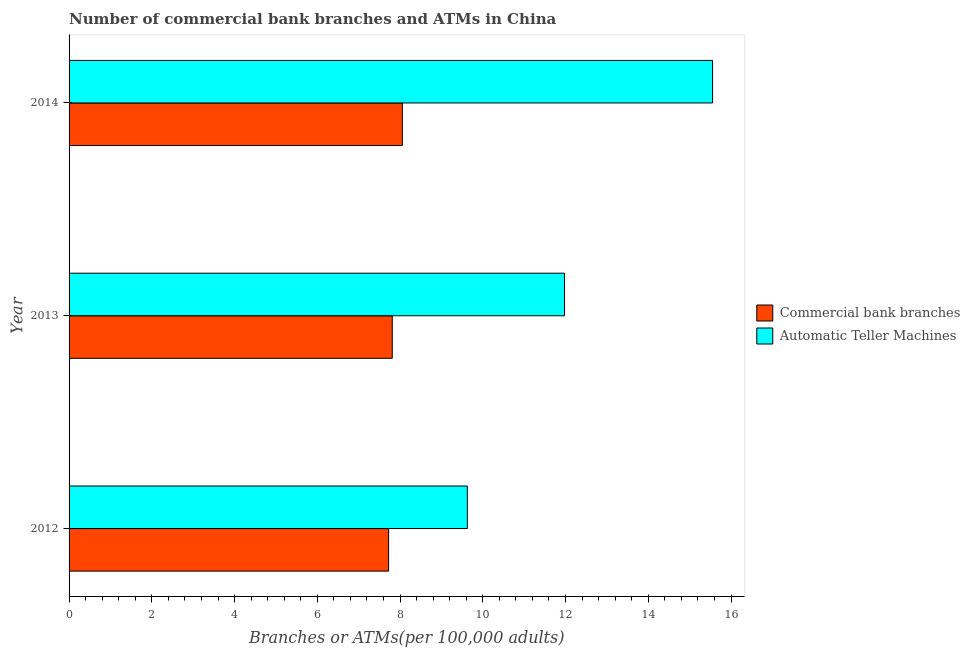How many different coloured bars are there?
Ensure brevity in your answer.  2. How many groups of bars are there?
Make the answer very short. 3. How many bars are there on the 1st tick from the top?
Keep it short and to the point. 2. How many bars are there on the 2nd tick from the bottom?
Keep it short and to the point. 2. What is the number of atms in 2014?
Your answer should be compact. 15.55. Across all years, what is the maximum number of commercal bank branches?
Give a very brief answer. 8.06. Across all years, what is the minimum number of commercal bank branches?
Make the answer very short. 7.72. In which year was the number of commercal bank branches maximum?
Offer a terse response. 2014. In which year was the number of commercal bank branches minimum?
Give a very brief answer. 2012. What is the total number of atms in the graph?
Keep it short and to the point. 37.16. What is the difference between the number of commercal bank branches in 2012 and that in 2013?
Provide a succinct answer. -0.09. What is the difference between the number of commercal bank branches in 2014 and the number of atms in 2013?
Your response must be concise. -3.92. What is the average number of commercal bank branches per year?
Offer a very short reply. 7.86. In the year 2014, what is the difference between the number of commercal bank branches and number of atms?
Your answer should be very brief. -7.5. What is the difference between the highest and the second highest number of atms?
Offer a very short reply. 3.58. What is the difference between the highest and the lowest number of commercal bank branches?
Provide a short and direct response. 0.33. In how many years, is the number of atms greater than the average number of atms taken over all years?
Ensure brevity in your answer.  1. Is the sum of the number of commercal bank branches in 2012 and 2013 greater than the maximum number of atms across all years?
Your answer should be compact. No. What does the 2nd bar from the top in 2012 represents?
Make the answer very short. Commercial bank branches. What does the 2nd bar from the bottom in 2014 represents?
Provide a succinct answer. Automatic Teller Machines. Are all the bars in the graph horizontal?
Your answer should be very brief. Yes. How many years are there in the graph?
Give a very brief answer. 3. What is the difference between two consecutive major ticks on the X-axis?
Provide a short and direct response. 2. Are the values on the major ticks of X-axis written in scientific E-notation?
Your answer should be very brief. No. How are the legend labels stacked?
Offer a terse response. Vertical. What is the title of the graph?
Your answer should be compact. Number of commercial bank branches and ATMs in China. What is the label or title of the X-axis?
Ensure brevity in your answer.  Branches or ATMs(per 100,0 adults). What is the Branches or ATMs(per 100,000 adults) of Commercial bank branches in 2012?
Offer a terse response. 7.72. What is the Branches or ATMs(per 100,000 adults) in Automatic Teller Machines in 2012?
Provide a succinct answer. 9.63. What is the Branches or ATMs(per 100,000 adults) in Commercial bank branches in 2013?
Ensure brevity in your answer.  7.81. What is the Branches or ATMs(per 100,000 adults) in Automatic Teller Machines in 2013?
Provide a succinct answer. 11.98. What is the Branches or ATMs(per 100,000 adults) in Commercial bank branches in 2014?
Offer a terse response. 8.06. What is the Branches or ATMs(per 100,000 adults) in Automatic Teller Machines in 2014?
Your response must be concise. 15.55. Across all years, what is the maximum Branches or ATMs(per 100,000 adults) of Commercial bank branches?
Offer a terse response. 8.06. Across all years, what is the maximum Branches or ATMs(per 100,000 adults) of Automatic Teller Machines?
Ensure brevity in your answer.  15.55. Across all years, what is the minimum Branches or ATMs(per 100,000 adults) of Commercial bank branches?
Offer a terse response. 7.72. Across all years, what is the minimum Branches or ATMs(per 100,000 adults) of Automatic Teller Machines?
Provide a succinct answer. 9.63. What is the total Branches or ATMs(per 100,000 adults) of Commercial bank branches in the graph?
Your answer should be very brief. 23.59. What is the total Branches or ATMs(per 100,000 adults) of Automatic Teller Machines in the graph?
Offer a terse response. 37.16. What is the difference between the Branches or ATMs(per 100,000 adults) in Commercial bank branches in 2012 and that in 2013?
Keep it short and to the point. -0.09. What is the difference between the Branches or ATMs(per 100,000 adults) of Automatic Teller Machines in 2012 and that in 2013?
Offer a terse response. -2.35. What is the difference between the Branches or ATMs(per 100,000 adults) of Commercial bank branches in 2012 and that in 2014?
Offer a terse response. -0.33. What is the difference between the Branches or ATMs(per 100,000 adults) of Automatic Teller Machines in 2012 and that in 2014?
Keep it short and to the point. -5.93. What is the difference between the Branches or ATMs(per 100,000 adults) of Commercial bank branches in 2013 and that in 2014?
Ensure brevity in your answer.  -0.24. What is the difference between the Branches or ATMs(per 100,000 adults) in Automatic Teller Machines in 2013 and that in 2014?
Offer a terse response. -3.58. What is the difference between the Branches or ATMs(per 100,000 adults) in Commercial bank branches in 2012 and the Branches or ATMs(per 100,000 adults) in Automatic Teller Machines in 2013?
Provide a succinct answer. -4.25. What is the difference between the Branches or ATMs(per 100,000 adults) in Commercial bank branches in 2012 and the Branches or ATMs(per 100,000 adults) in Automatic Teller Machines in 2014?
Offer a terse response. -7.83. What is the difference between the Branches or ATMs(per 100,000 adults) in Commercial bank branches in 2013 and the Branches or ATMs(per 100,000 adults) in Automatic Teller Machines in 2014?
Your answer should be very brief. -7.74. What is the average Branches or ATMs(per 100,000 adults) in Commercial bank branches per year?
Offer a terse response. 7.86. What is the average Branches or ATMs(per 100,000 adults) in Automatic Teller Machines per year?
Provide a succinct answer. 12.39. In the year 2012, what is the difference between the Branches or ATMs(per 100,000 adults) in Commercial bank branches and Branches or ATMs(per 100,000 adults) in Automatic Teller Machines?
Make the answer very short. -1.9. In the year 2013, what is the difference between the Branches or ATMs(per 100,000 adults) in Commercial bank branches and Branches or ATMs(per 100,000 adults) in Automatic Teller Machines?
Provide a succinct answer. -4.16. In the year 2014, what is the difference between the Branches or ATMs(per 100,000 adults) of Commercial bank branches and Branches or ATMs(per 100,000 adults) of Automatic Teller Machines?
Your answer should be very brief. -7.5. What is the ratio of the Branches or ATMs(per 100,000 adults) in Automatic Teller Machines in 2012 to that in 2013?
Keep it short and to the point. 0.8. What is the ratio of the Branches or ATMs(per 100,000 adults) of Commercial bank branches in 2012 to that in 2014?
Your answer should be compact. 0.96. What is the ratio of the Branches or ATMs(per 100,000 adults) of Automatic Teller Machines in 2012 to that in 2014?
Offer a very short reply. 0.62. What is the ratio of the Branches or ATMs(per 100,000 adults) of Commercial bank branches in 2013 to that in 2014?
Give a very brief answer. 0.97. What is the ratio of the Branches or ATMs(per 100,000 adults) in Automatic Teller Machines in 2013 to that in 2014?
Your answer should be compact. 0.77. What is the difference between the highest and the second highest Branches or ATMs(per 100,000 adults) in Commercial bank branches?
Provide a succinct answer. 0.24. What is the difference between the highest and the second highest Branches or ATMs(per 100,000 adults) of Automatic Teller Machines?
Keep it short and to the point. 3.58. What is the difference between the highest and the lowest Branches or ATMs(per 100,000 adults) of Commercial bank branches?
Offer a very short reply. 0.33. What is the difference between the highest and the lowest Branches or ATMs(per 100,000 adults) of Automatic Teller Machines?
Ensure brevity in your answer.  5.93. 